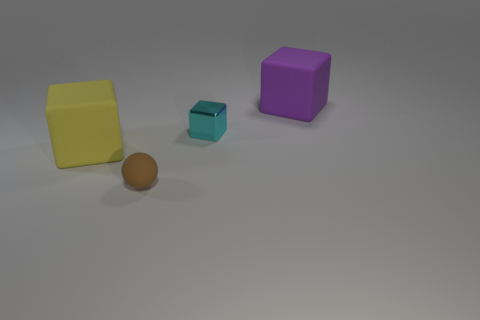What color is the big object that is on the right side of the object that is in front of the large yellow matte block? purple 